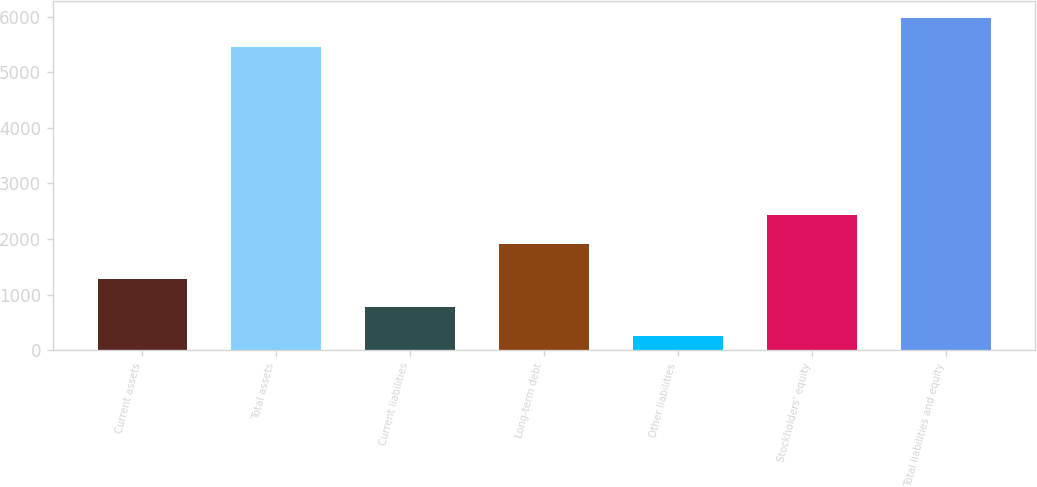Convert chart. <chart><loc_0><loc_0><loc_500><loc_500><bar_chart><fcel>Current assets<fcel>Total assets<fcel>Current liabilities<fcel>Long-term debt<fcel>Other liabilities<fcel>Stockholders' equity<fcel>Total liabilities and equity<nl><fcel>1288.62<fcel>5454.3<fcel>767.91<fcel>1911.9<fcel>247.2<fcel>2432.61<fcel>5975.01<nl></chart> 